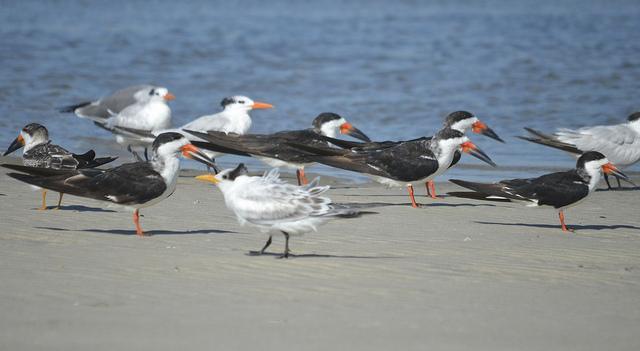How many black and white birds appear in this scene?
Give a very brief answer. 6. Are they swimming?
Keep it brief. No. What type of bird is this?
Concise answer only. Seagull. 